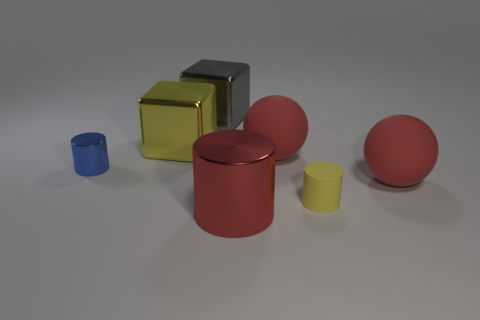Subtract all large red cylinders. How many cylinders are left? 2 Subtract 3 cylinders. How many cylinders are left? 0 Subtract 0 blue cubes. How many objects are left? 7 Subtract all spheres. How many objects are left? 5 Subtract all gray blocks. Subtract all purple cylinders. How many blocks are left? 1 Subtract all gray balls. How many brown cubes are left? 0 Subtract all small yellow blocks. Subtract all rubber balls. How many objects are left? 5 Add 1 tiny blue cylinders. How many tiny blue cylinders are left? 2 Add 2 large red matte cubes. How many large red matte cubes exist? 2 Add 2 gray metal objects. How many objects exist? 9 